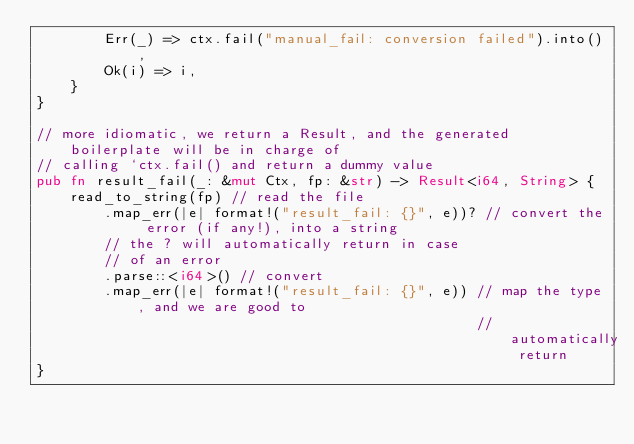<code> <loc_0><loc_0><loc_500><loc_500><_Rust_>        Err(_) => ctx.fail("manual_fail: conversion failed").into(),
        Ok(i) => i,
    }
}

// more idiomatic, we return a Result, and the generated boilerplate will be in charge of
// calling `ctx.fail() and return a dummy value
pub fn result_fail(_: &mut Ctx, fp: &str) -> Result<i64, String> {
    read_to_string(fp) // read the file
        .map_err(|e| format!("result_fail: {}", e))? // convert the error (if any!), into a string
        // the ? will automatically return in case
        // of an error
        .parse::<i64>() // convert
        .map_err(|e| format!("result_fail: {}", e)) // map the type, and we are good to
                                                    // automatically return
}
</code> 